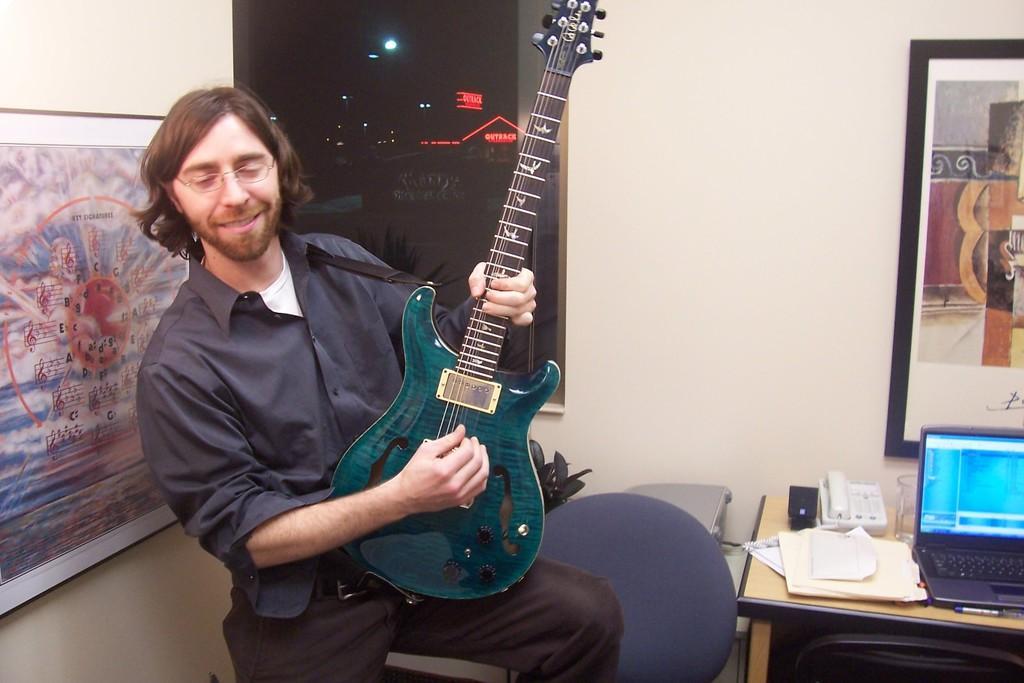Could you give a brief overview of what you see in this image? This man is sitting on a bench and playing guitar. On wall there are different type of photos. On this table there is a telephone, papers, glass and laptop. We can able to see chair and plant. 